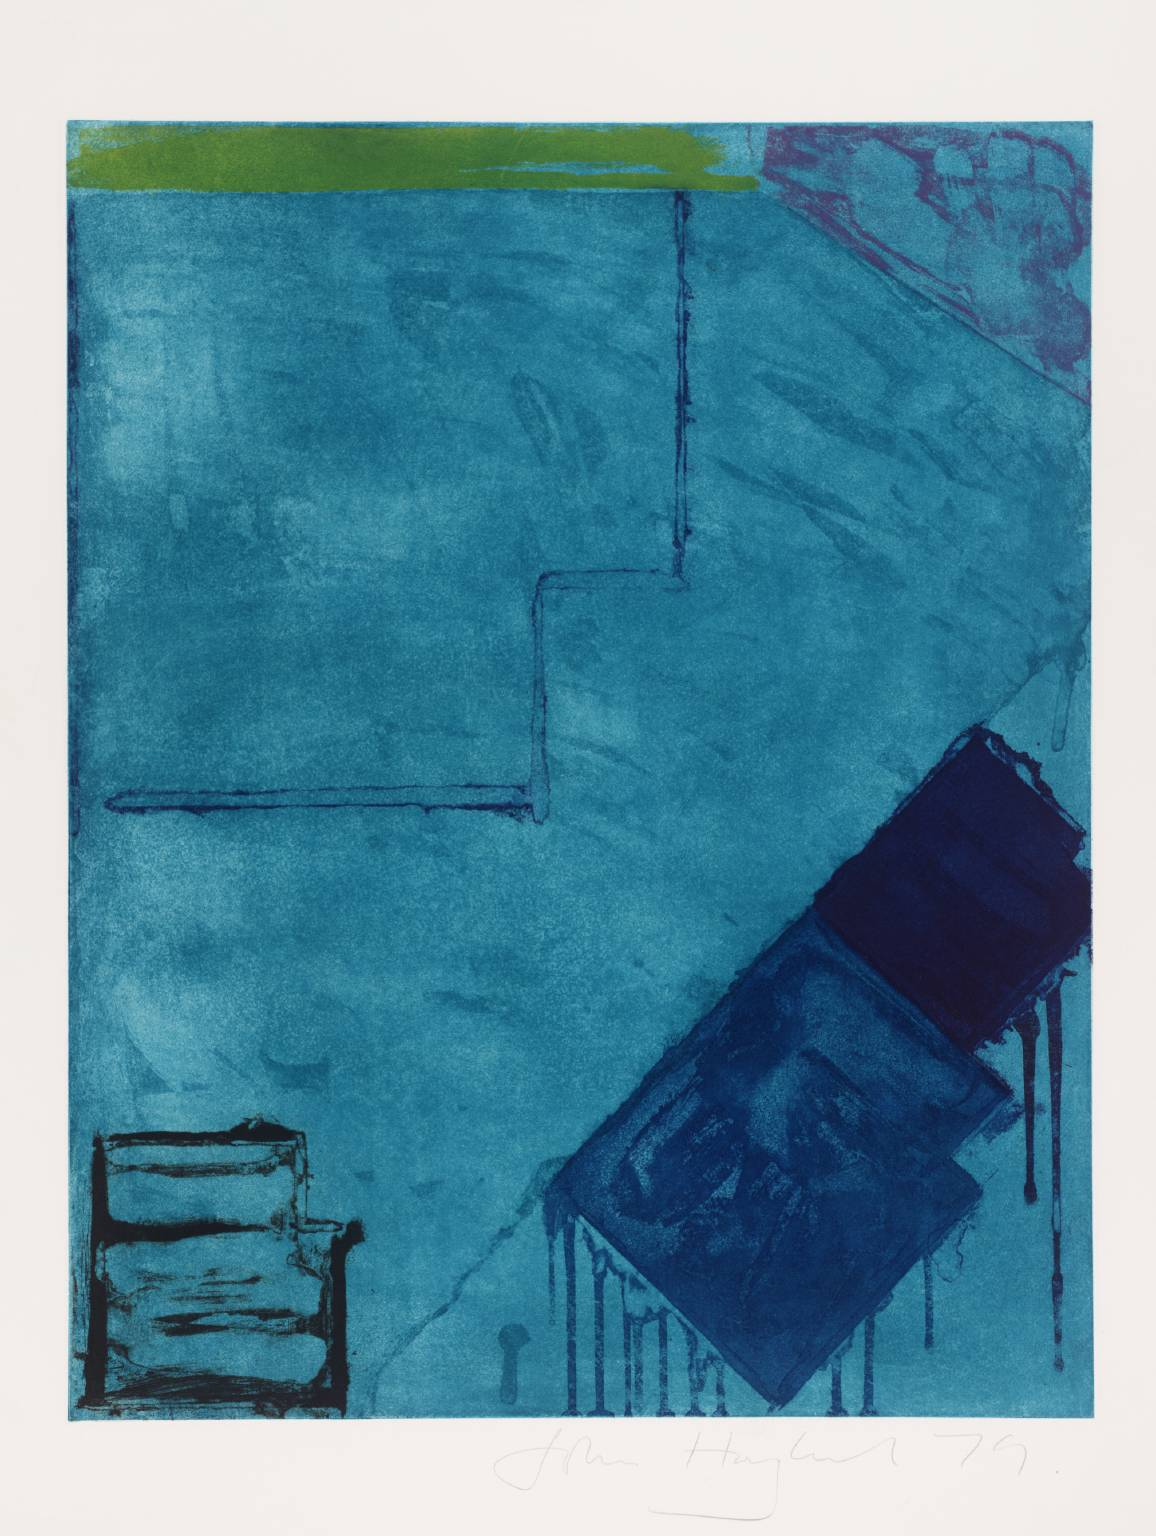What are the key elements in this picture? The image presents an abstract art piece that appears to be a print. Dominating the canvas is a sea of blue, a symphony of different shades and textures. Some areas of the blue are more solid, while others are more transparent, creating a sense of depth and movement. 

At the top of the image, a strip of green cuts across, adding a contrasting color to the blue. On the right side, a pinkish-red line stands out, breaking the monotony of the blue. The image is divided into different sections, with a dark blue rectangle on the right side and a lighter blue square on the left. 

The art style is abstract, leaving room for interpretation and imagination. The genre is likely printmaking, given the texture and the layering of colors. The image, with its bold colors and abstract shapes, invites viewers to explore and interpret its meaning. 